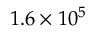Convert formula to latex. <formula><loc_0><loc_0><loc_500><loc_500>1 . 6 \times 1 0 ^ { 5 }</formula> 